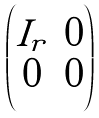<formula> <loc_0><loc_0><loc_500><loc_500>\begin{pmatrix} I _ { r } & 0 \\ 0 & 0 \end{pmatrix}</formula> 